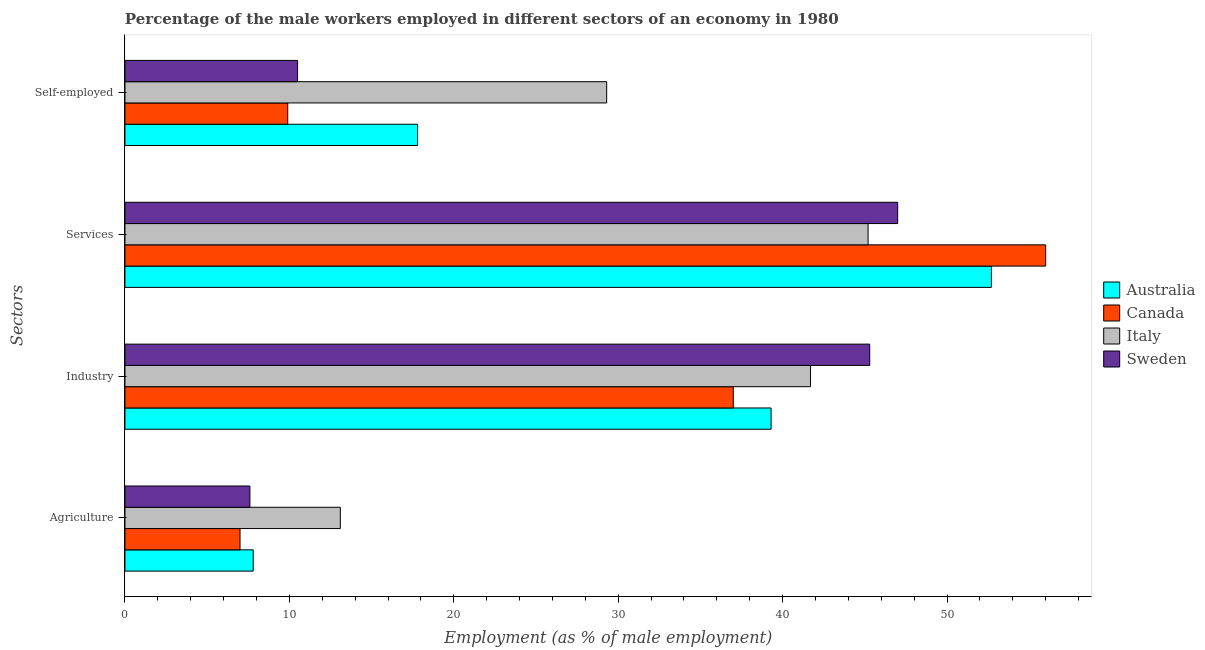How many different coloured bars are there?
Offer a terse response. 4. How many groups of bars are there?
Your answer should be very brief. 4. Are the number of bars per tick equal to the number of legend labels?
Provide a short and direct response. Yes. How many bars are there on the 3rd tick from the bottom?
Offer a very short reply. 4. What is the label of the 1st group of bars from the top?
Provide a short and direct response. Self-employed. Across all countries, what is the maximum percentage of male workers in agriculture?
Your answer should be compact. 13.1. In which country was the percentage of self employed male workers maximum?
Your answer should be very brief. Italy. In which country was the percentage of male workers in agriculture minimum?
Your answer should be compact. Canada. What is the total percentage of male workers in industry in the graph?
Keep it short and to the point. 163.3. What is the difference between the percentage of male workers in agriculture in Sweden and that in Canada?
Give a very brief answer. 0.6. What is the difference between the percentage of male workers in agriculture in Canada and the percentage of self employed male workers in Australia?
Give a very brief answer. -10.8. What is the average percentage of self employed male workers per country?
Your response must be concise. 16.87. What is the difference between the percentage of male workers in agriculture and percentage of self employed male workers in Canada?
Give a very brief answer. -2.9. What is the ratio of the percentage of male workers in agriculture in Australia to that in Italy?
Offer a very short reply. 0.6. Is the percentage of male workers in industry in Italy less than that in Canada?
Give a very brief answer. No. What is the difference between the highest and the second highest percentage of male workers in agriculture?
Keep it short and to the point. 5.3. What is the difference between the highest and the lowest percentage of male workers in industry?
Provide a succinct answer. 8.3. Is it the case that in every country, the sum of the percentage of male workers in services and percentage of male workers in industry is greater than the sum of percentage of self employed male workers and percentage of male workers in agriculture?
Your answer should be very brief. No. What does the 1st bar from the top in Agriculture represents?
Ensure brevity in your answer.  Sweden. What does the 2nd bar from the bottom in Industry represents?
Provide a succinct answer. Canada. Are all the bars in the graph horizontal?
Provide a short and direct response. Yes. Where does the legend appear in the graph?
Provide a succinct answer. Center right. How many legend labels are there?
Make the answer very short. 4. How are the legend labels stacked?
Give a very brief answer. Vertical. What is the title of the graph?
Offer a very short reply. Percentage of the male workers employed in different sectors of an economy in 1980. Does "Italy" appear as one of the legend labels in the graph?
Your response must be concise. Yes. What is the label or title of the X-axis?
Ensure brevity in your answer.  Employment (as % of male employment). What is the label or title of the Y-axis?
Your answer should be very brief. Sectors. What is the Employment (as % of male employment) of Australia in Agriculture?
Your response must be concise. 7.8. What is the Employment (as % of male employment) of Italy in Agriculture?
Provide a succinct answer. 13.1. What is the Employment (as % of male employment) of Sweden in Agriculture?
Your answer should be compact. 7.6. What is the Employment (as % of male employment) of Australia in Industry?
Make the answer very short. 39.3. What is the Employment (as % of male employment) in Canada in Industry?
Ensure brevity in your answer.  37. What is the Employment (as % of male employment) of Italy in Industry?
Provide a succinct answer. 41.7. What is the Employment (as % of male employment) of Sweden in Industry?
Your answer should be compact. 45.3. What is the Employment (as % of male employment) in Australia in Services?
Make the answer very short. 52.7. What is the Employment (as % of male employment) in Italy in Services?
Provide a succinct answer. 45.2. What is the Employment (as % of male employment) of Australia in Self-employed?
Make the answer very short. 17.8. What is the Employment (as % of male employment) of Canada in Self-employed?
Ensure brevity in your answer.  9.9. What is the Employment (as % of male employment) in Italy in Self-employed?
Keep it short and to the point. 29.3. Across all Sectors, what is the maximum Employment (as % of male employment) of Australia?
Your response must be concise. 52.7. Across all Sectors, what is the maximum Employment (as % of male employment) of Canada?
Provide a succinct answer. 56. Across all Sectors, what is the maximum Employment (as % of male employment) in Italy?
Your answer should be very brief. 45.2. Across all Sectors, what is the minimum Employment (as % of male employment) of Australia?
Your answer should be very brief. 7.8. Across all Sectors, what is the minimum Employment (as % of male employment) of Italy?
Your response must be concise. 13.1. Across all Sectors, what is the minimum Employment (as % of male employment) of Sweden?
Offer a terse response. 7.6. What is the total Employment (as % of male employment) in Australia in the graph?
Offer a terse response. 117.6. What is the total Employment (as % of male employment) in Canada in the graph?
Offer a very short reply. 109.9. What is the total Employment (as % of male employment) of Italy in the graph?
Offer a terse response. 129.3. What is the total Employment (as % of male employment) of Sweden in the graph?
Ensure brevity in your answer.  110.4. What is the difference between the Employment (as % of male employment) in Australia in Agriculture and that in Industry?
Offer a terse response. -31.5. What is the difference between the Employment (as % of male employment) in Canada in Agriculture and that in Industry?
Give a very brief answer. -30. What is the difference between the Employment (as % of male employment) of Italy in Agriculture and that in Industry?
Your response must be concise. -28.6. What is the difference between the Employment (as % of male employment) of Sweden in Agriculture and that in Industry?
Give a very brief answer. -37.7. What is the difference between the Employment (as % of male employment) in Australia in Agriculture and that in Services?
Your answer should be compact. -44.9. What is the difference between the Employment (as % of male employment) of Canada in Agriculture and that in Services?
Give a very brief answer. -49. What is the difference between the Employment (as % of male employment) of Italy in Agriculture and that in Services?
Make the answer very short. -32.1. What is the difference between the Employment (as % of male employment) of Sweden in Agriculture and that in Services?
Your answer should be very brief. -39.4. What is the difference between the Employment (as % of male employment) of Australia in Agriculture and that in Self-employed?
Offer a terse response. -10. What is the difference between the Employment (as % of male employment) in Italy in Agriculture and that in Self-employed?
Offer a very short reply. -16.2. What is the difference between the Employment (as % of male employment) in Australia in Industry and that in Self-employed?
Provide a short and direct response. 21.5. What is the difference between the Employment (as % of male employment) in Canada in Industry and that in Self-employed?
Offer a terse response. 27.1. What is the difference between the Employment (as % of male employment) in Italy in Industry and that in Self-employed?
Offer a terse response. 12.4. What is the difference between the Employment (as % of male employment) of Sweden in Industry and that in Self-employed?
Offer a terse response. 34.8. What is the difference between the Employment (as % of male employment) in Australia in Services and that in Self-employed?
Give a very brief answer. 34.9. What is the difference between the Employment (as % of male employment) of Canada in Services and that in Self-employed?
Provide a short and direct response. 46.1. What is the difference between the Employment (as % of male employment) of Sweden in Services and that in Self-employed?
Make the answer very short. 36.5. What is the difference between the Employment (as % of male employment) in Australia in Agriculture and the Employment (as % of male employment) in Canada in Industry?
Your response must be concise. -29.2. What is the difference between the Employment (as % of male employment) in Australia in Agriculture and the Employment (as % of male employment) in Italy in Industry?
Give a very brief answer. -33.9. What is the difference between the Employment (as % of male employment) of Australia in Agriculture and the Employment (as % of male employment) of Sweden in Industry?
Give a very brief answer. -37.5. What is the difference between the Employment (as % of male employment) of Canada in Agriculture and the Employment (as % of male employment) of Italy in Industry?
Make the answer very short. -34.7. What is the difference between the Employment (as % of male employment) of Canada in Agriculture and the Employment (as % of male employment) of Sweden in Industry?
Your response must be concise. -38.3. What is the difference between the Employment (as % of male employment) in Italy in Agriculture and the Employment (as % of male employment) in Sweden in Industry?
Your answer should be compact. -32.2. What is the difference between the Employment (as % of male employment) of Australia in Agriculture and the Employment (as % of male employment) of Canada in Services?
Your answer should be very brief. -48.2. What is the difference between the Employment (as % of male employment) in Australia in Agriculture and the Employment (as % of male employment) in Italy in Services?
Give a very brief answer. -37.4. What is the difference between the Employment (as % of male employment) of Australia in Agriculture and the Employment (as % of male employment) of Sweden in Services?
Your answer should be very brief. -39.2. What is the difference between the Employment (as % of male employment) of Canada in Agriculture and the Employment (as % of male employment) of Italy in Services?
Provide a succinct answer. -38.2. What is the difference between the Employment (as % of male employment) in Canada in Agriculture and the Employment (as % of male employment) in Sweden in Services?
Ensure brevity in your answer.  -40. What is the difference between the Employment (as % of male employment) in Italy in Agriculture and the Employment (as % of male employment) in Sweden in Services?
Provide a succinct answer. -33.9. What is the difference between the Employment (as % of male employment) in Australia in Agriculture and the Employment (as % of male employment) in Italy in Self-employed?
Provide a short and direct response. -21.5. What is the difference between the Employment (as % of male employment) in Australia in Agriculture and the Employment (as % of male employment) in Sweden in Self-employed?
Provide a short and direct response. -2.7. What is the difference between the Employment (as % of male employment) of Canada in Agriculture and the Employment (as % of male employment) of Italy in Self-employed?
Provide a short and direct response. -22.3. What is the difference between the Employment (as % of male employment) in Canada in Agriculture and the Employment (as % of male employment) in Sweden in Self-employed?
Ensure brevity in your answer.  -3.5. What is the difference between the Employment (as % of male employment) of Italy in Agriculture and the Employment (as % of male employment) of Sweden in Self-employed?
Your answer should be compact. 2.6. What is the difference between the Employment (as % of male employment) of Australia in Industry and the Employment (as % of male employment) of Canada in Services?
Provide a succinct answer. -16.7. What is the difference between the Employment (as % of male employment) of Italy in Industry and the Employment (as % of male employment) of Sweden in Services?
Give a very brief answer. -5.3. What is the difference between the Employment (as % of male employment) of Australia in Industry and the Employment (as % of male employment) of Canada in Self-employed?
Your answer should be compact. 29.4. What is the difference between the Employment (as % of male employment) in Australia in Industry and the Employment (as % of male employment) in Sweden in Self-employed?
Make the answer very short. 28.8. What is the difference between the Employment (as % of male employment) of Canada in Industry and the Employment (as % of male employment) of Sweden in Self-employed?
Offer a very short reply. 26.5. What is the difference between the Employment (as % of male employment) in Italy in Industry and the Employment (as % of male employment) in Sweden in Self-employed?
Your answer should be very brief. 31.2. What is the difference between the Employment (as % of male employment) of Australia in Services and the Employment (as % of male employment) of Canada in Self-employed?
Provide a succinct answer. 42.8. What is the difference between the Employment (as % of male employment) in Australia in Services and the Employment (as % of male employment) in Italy in Self-employed?
Give a very brief answer. 23.4. What is the difference between the Employment (as % of male employment) of Australia in Services and the Employment (as % of male employment) of Sweden in Self-employed?
Your answer should be very brief. 42.2. What is the difference between the Employment (as % of male employment) in Canada in Services and the Employment (as % of male employment) in Italy in Self-employed?
Provide a short and direct response. 26.7. What is the difference between the Employment (as % of male employment) in Canada in Services and the Employment (as % of male employment) in Sweden in Self-employed?
Your answer should be very brief. 45.5. What is the difference between the Employment (as % of male employment) of Italy in Services and the Employment (as % of male employment) of Sweden in Self-employed?
Your answer should be compact. 34.7. What is the average Employment (as % of male employment) of Australia per Sectors?
Provide a succinct answer. 29.4. What is the average Employment (as % of male employment) of Canada per Sectors?
Keep it short and to the point. 27.48. What is the average Employment (as % of male employment) of Italy per Sectors?
Make the answer very short. 32.33. What is the average Employment (as % of male employment) in Sweden per Sectors?
Your response must be concise. 27.6. What is the difference between the Employment (as % of male employment) of Australia and Employment (as % of male employment) of Sweden in Agriculture?
Provide a short and direct response. 0.2. What is the difference between the Employment (as % of male employment) of Canada and Employment (as % of male employment) of Italy in Agriculture?
Your answer should be very brief. -6.1. What is the difference between the Employment (as % of male employment) in Canada and Employment (as % of male employment) in Sweden in Agriculture?
Ensure brevity in your answer.  -0.6. What is the difference between the Employment (as % of male employment) of Italy and Employment (as % of male employment) of Sweden in Agriculture?
Keep it short and to the point. 5.5. What is the difference between the Employment (as % of male employment) in Australia and Employment (as % of male employment) in Sweden in Industry?
Keep it short and to the point. -6. What is the difference between the Employment (as % of male employment) in Canada and Employment (as % of male employment) in Italy in Industry?
Your answer should be very brief. -4.7. What is the difference between the Employment (as % of male employment) of Italy and Employment (as % of male employment) of Sweden in Industry?
Ensure brevity in your answer.  -3.6. What is the difference between the Employment (as % of male employment) in Australia and Employment (as % of male employment) in Italy in Services?
Provide a succinct answer. 7.5. What is the difference between the Employment (as % of male employment) of Canada and Employment (as % of male employment) of Italy in Services?
Keep it short and to the point. 10.8. What is the difference between the Employment (as % of male employment) of Canada and Employment (as % of male employment) of Sweden in Services?
Ensure brevity in your answer.  9. What is the difference between the Employment (as % of male employment) in Australia and Employment (as % of male employment) in Canada in Self-employed?
Your response must be concise. 7.9. What is the difference between the Employment (as % of male employment) in Australia and Employment (as % of male employment) in Sweden in Self-employed?
Make the answer very short. 7.3. What is the difference between the Employment (as % of male employment) of Canada and Employment (as % of male employment) of Italy in Self-employed?
Keep it short and to the point. -19.4. What is the difference between the Employment (as % of male employment) in Italy and Employment (as % of male employment) in Sweden in Self-employed?
Give a very brief answer. 18.8. What is the ratio of the Employment (as % of male employment) of Australia in Agriculture to that in Industry?
Your response must be concise. 0.2. What is the ratio of the Employment (as % of male employment) in Canada in Agriculture to that in Industry?
Your answer should be compact. 0.19. What is the ratio of the Employment (as % of male employment) in Italy in Agriculture to that in Industry?
Provide a succinct answer. 0.31. What is the ratio of the Employment (as % of male employment) of Sweden in Agriculture to that in Industry?
Your response must be concise. 0.17. What is the ratio of the Employment (as % of male employment) of Australia in Agriculture to that in Services?
Offer a terse response. 0.15. What is the ratio of the Employment (as % of male employment) of Canada in Agriculture to that in Services?
Provide a succinct answer. 0.12. What is the ratio of the Employment (as % of male employment) of Italy in Agriculture to that in Services?
Give a very brief answer. 0.29. What is the ratio of the Employment (as % of male employment) in Sweden in Agriculture to that in Services?
Your response must be concise. 0.16. What is the ratio of the Employment (as % of male employment) of Australia in Agriculture to that in Self-employed?
Give a very brief answer. 0.44. What is the ratio of the Employment (as % of male employment) of Canada in Agriculture to that in Self-employed?
Your answer should be compact. 0.71. What is the ratio of the Employment (as % of male employment) of Italy in Agriculture to that in Self-employed?
Offer a terse response. 0.45. What is the ratio of the Employment (as % of male employment) of Sweden in Agriculture to that in Self-employed?
Offer a very short reply. 0.72. What is the ratio of the Employment (as % of male employment) of Australia in Industry to that in Services?
Offer a very short reply. 0.75. What is the ratio of the Employment (as % of male employment) of Canada in Industry to that in Services?
Your response must be concise. 0.66. What is the ratio of the Employment (as % of male employment) of Italy in Industry to that in Services?
Ensure brevity in your answer.  0.92. What is the ratio of the Employment (as % of male employment) in Sweden in Industry to that in Services?
Your answer should be compact. 0.96. What is the ratio of the Employment (as % of male employment) in Australia in Industry to that in Self-employed?
Your response must be concise. 2.21. What is the ratio of the Employment (as % of male employment) in Canada in Industry to that in Self-employed?
Your answer should be compact. 3.74. What is the ratio of the Employment (as % of male employment) of Italy in Industry to that in Self-employed?
Offer a terse response. 1.42. What is the ratio of the Employment (as % of male employment) in Sweden in Industry to that in Self-employed?
Your answer should be very brief. 4.31. What is the ratio of the Employment (as % of male employment) in Australia in Services to that in Self-employed?
Keep it short and to the point. 2.96. What is the ratio of the Employment (as % of male employment) of Canada in Services to that in Self-employed?
Provide a succinct answer. 5.66. What is the ratio of the Employment (as % of male employment) in Italy in Services to that in Self-employed?
Make the answer very short. 1.54. What is the ratio of the Employment (as % of male employment) of Sweden in Services to that in Self-employed?
Your answer should be very brief. 4.48. What is the difference between the highest and the second highest Employment (as % of male employment) in Canada?
Make the answer very short. 19. What is the difference between the highest and the second highest Employment (as % of male employment) of Sweden?
Provide a short and direct response. 1.7. What is the difference between the highest and the lowest Employment (as % of male employment) of Australia?
Provide a short and direct response. 44.9. What is the difference between the highest and the lowest Employment (as % of male employment) in Italy?
Make the answer very short. 32.1. What is the difference between the highest and the lowest Employment (as % of male employment) of Sweden?
Provide a short and direct response. 39.4. 